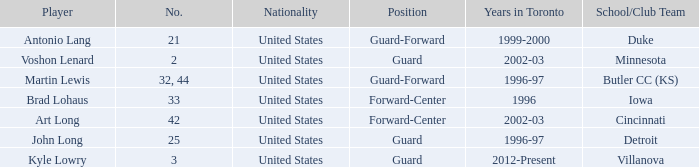Which athlete dons the number 42? Art Long. 